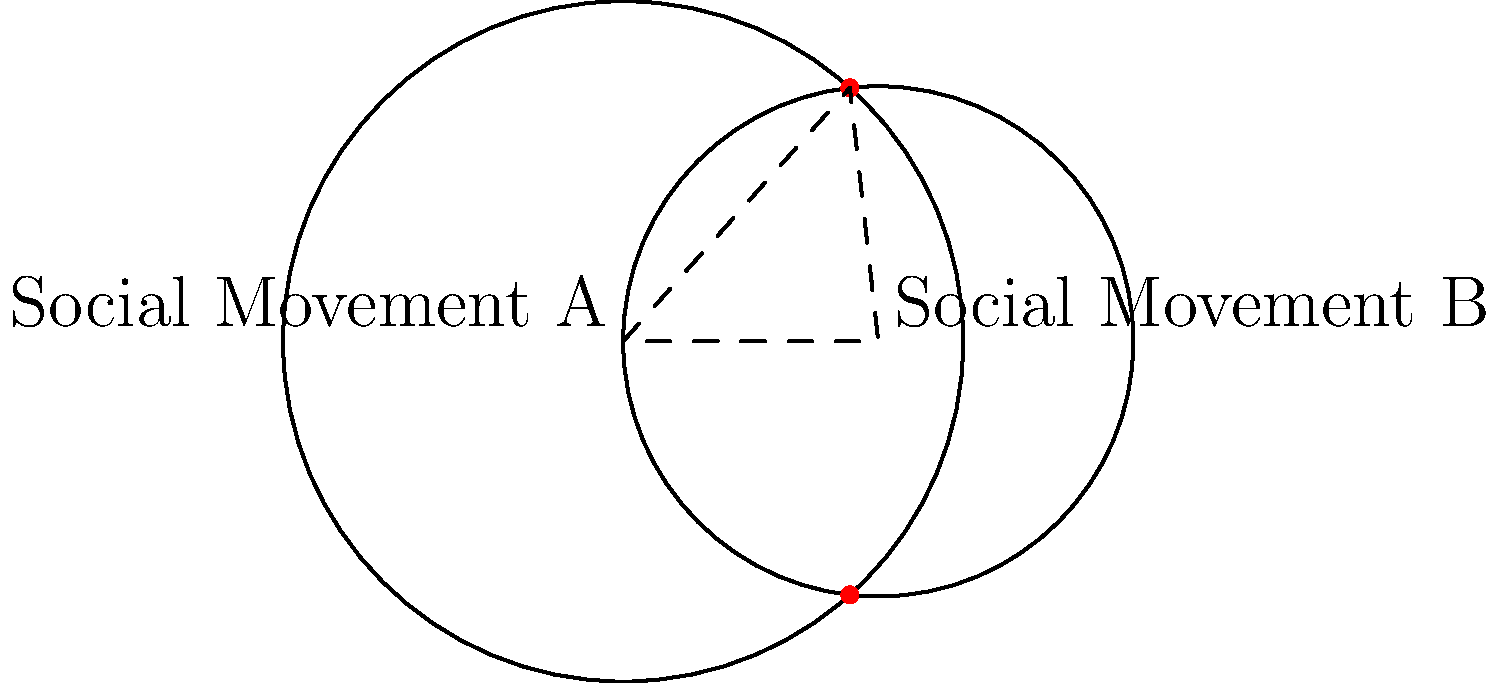Two social movements, represented by intersecting circles, are gaining traction on your social media platform. Movement A has a reach radius of 2 units, while Movement B has a reach radius of 1.5 units. The centers of these movements are 1.5 units apart. Calculate the area of overlap between these two movements, representing the shared audience and common goals. Round your answer to two decimal places. To solve this problem, we'll use the formula for the area of intersection between two circles:

1) First, calculate the distance between the centers (d):
   $d = 1.5$ (given in the question)

2) Use the formula for the area of intersection:
   $A = r_1^2 \arccos(\frac{d^2 + r_1^2 - r_2^2}{2dr_1}) + r_2^2 \arccos(\frac{d^2 + r_2^2 - r_1^2}{2dr_2}) - \frac{1}{2}\sqrt{(-d+r_1+r_2)(d+r_1-r_2)(d-r_1+r_2)(d+r_1+r_2)}$

   Where $r_1 = 2$ and $r_2 = 1.5$

3) Substitute the values:
   $A = 2^2 \arccos(\frac{1.5^2 + 2^2 - 1.5^2}{2 \cdot 1.5 \cdot 2}) + 1.5^2 \arccos(\frac{1.5^2 + 1.5^2 - 2^2}{2 \cdot 1.5 \cdot 1.5}) - \frac{1}{2}\sqrt{(-1.5+2+1.5)(1.5+2-1.5)(1.5-2+1.5)(1.5+2+1.5)}$

4) Simplify:
   $A = 4 \arccos(0.8125) + 2.25 \arccos(0.1667) - \frac{1}{2}\sqrt{2 \cdot 2 \cdot 1 \cdot 5}$

5) Calculate:
   $A \approx 4 \cdot 0.6155 + 2.25 \cdot 1.4033 - \frac{1}{2}\sqrt{20}$
   $A \approx 2.462 + 3.1574 - 2.2361$
   $A \approx 3.3833$

6) Round to two decimal places:
   $A \approx 3.38$
Answer: 3.38 square units 